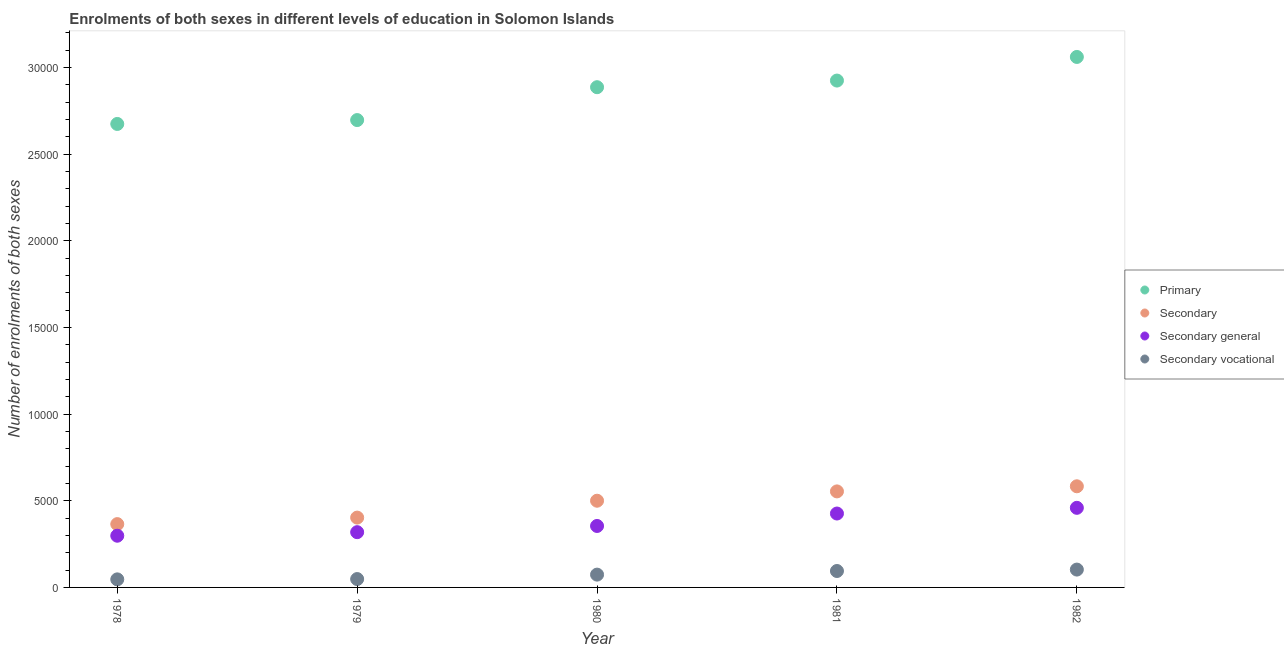How many different coloured dotlines are there?
Provide a short and direct response. 4. What is the number of enrolments in secondary vocational education in 1982?
Your response must be concise. 1030. Across all years, what is the maximum number of enrolments in primary education?
Provide a succinct answer. 3.06e+04. Across all years, what is the minimum number of enrolments in secondary general education?
Provide a short and direct response. 2984. In which year was the number of enrolments in secondary vocational education minimum?
Provide a succinct answer. 1978. What is the total number of enrolments in secondary education in the graph?
Offer a very short reply. 2.41e+04. What is the difference between the number of enrolments in secondary vocational education in 1979 and that in 1982?
Provide a succinct answer. -547. What is the difference between the number of enrolments in secondary general education in 1982 and the number of enrolments in secondary education in 1978?
Ensure brevity in your answer.  940. What is the average number of enrolments in primary education per year?
Give a very brief answer. 2.85e+04. In the year 1978, what is the difference between the number of enrolments in secondary general education and number of enrolments in primary education?
Offer a very short reply. -2.38e+04. In how many years, is the number of enrolments in secondary general education greater than 4000?
Your answer should be compact. 2. What is the ratio of the number of enrolments in primary education in 1979 to that in 1980?
Keep it short and to the point. 0.93. Is the number of enrolments in primary education in 1978 less than that in 1982?
Provide a short and direct response. Yes. What is the difference between the highest and the second highest number of enrolments in primary education?
Your answer should be very brief. 1363. What is the difference between the highest and the lowest number of enrolments in secondary general education?
Provide a short and direct response. 1610. In how many years, is the number of enrolments in secondary education greater than the average number of enrolments in secondary education taken over all years?
Give a very brief answer. 3. Is the number of enrolments in secondary vocational education strictly greater than the number of enrolments in secondary general education over the years?
Make the answer very short. No. Is the number of enrolments in secondary general education strictly less than the number of enrolments in primary education over the years?
Offer a terse response. Yes. How many dotlines are there?
Your response must be concise. 4. How many years are there in the graph?
Your answer should be very brief. 5. What is the difference between two consecutive major ticks on the Y-axis?
Provide a succinct answer. 5000. Are the values on the major ticks of Y-axis written in scientific E-notation?
Keep it short and to the point. No. Does the graph contain any zero values?
Give a very brief answer. No. How are the legend labels stacked?
Your answer should be compact. Vertical. What is the title of the graph?
Provide a short and direct response. Enrolments of both sexes in different levels of education in Solomon Islands. What is the label or title of the X-axis?
Ensure brevity in your answer.  Year. What is the label or title of the Y-axis?
Make the answer very short. Number of enrolments of both sexes. What is the Number of enrolments of both sexes in Primary in 1978?
Provide a succinct answer. 2.67e+04. What is the Number of enrolments of both sexes in Secondary in 1978?
Provide a short and direct response. 3654. What is the Number of enrolments of both sexes of Secondary general in 1978?
Offer a very short reply. 2984. What is the Number of enrolments of both sexes of Secondary vocational in 1978?
Your answer should be compact. 465. What is the Number of enrolments of both sexes in Primary in 1979?
Your response must be concise. 2.70e+04. What is the Number of enrolments of both sexes of Secondary in 1979?
Make the answer very short. 4030. What is the Number of enrolments of both sexes in Secondary general in 1979?
Your answer should be very brief. 3189. What is the Number of enrolments of both sexes in Secondary vocational in 1979?
Provide a short and direct response. 483. What is the Number of enrolments of both sexes of Primary in 1980?
Provide a succinct answer. 2.89e+04. What is the Number of enrolments of both sexes of Secondary in 1980?
Your answer should be compact. 5004. What is the Number of enrolments of both sexes of Secondary general in 1980?
Keep it short and to the point. 3547. What is the Number of enrolments of both sexes in Secondary vocational in 1980?
Offer a very short reply. 739. What is the Number of enrolments of both sexes in Primary in 1981?
Ensure brevity in your answer.  2.93e+04. What is the Number of enrolments of both sexes of Secondary in 1981?
Make the answer very short. 5542. What is the Number of enrolments of both sexes in Secondary general in 1981?
Ensure brevity in your answer.  4265. What is the Number of enrolments of both sexes in Secondary vocational in 1981?
Make the answer very short. 948. What is the Number of enrolments of both sexes in Primary in 1982?
Give a very brief answer. 3.06e+04. What is the Number of enrolments of both sexes of Secondary in 1982?
Offer a very short reply. 5837. What is the Number of enrolments of both sexes in Secondary general in 1982?
Offer a very short reply. 4594. What is the Number of enrolments of both sexes of Secondary vocational in 1982?
Offer a very short reply. 1030. Across all years, what is the maximum Number of enrolments of both sexes of Primary?
Provide a short and direct response. 3.06e+04. Across all years, what is the maximum Number of enrolments of both sexes of Secondary?
Provide a succinct answer. 5837. Across all years, what is the maximum Number of enrolments of both sexes of Secondary general?
Ensure brevity in your answer.  4594. Across all years, what is the maximum Number of enrolments of both sexes in Secondary vocational?
Your answer should be compact. 1030. Across all years, what is the minimum Number of enrolments of both sexes of Primary?
Make the answer very short. 2.67e+04. Across all years, what is the minimum Number of enrolments of both sexes of Secondary?
Make the answer very short. 3654. Across all years, what is the minimum Number of enrolments of both sexes in Secondary general?
Your answer should be compact. 2984. Across all years, what is the minimum Number of enrolments of both sexes of Secondary vocational?
Your answer should be compact. 465. What is the total Number of enrolments of both sexes in Primary in the graph?
Make the answer very short. 1.42e+05. What is the total Number of enrolments of both sexes of Secondary in the graph?
Ensure brevity in your answer.  2.41e+04. What is the total Number of enrolments of both sexes of Secondary general in the graph?
Offer a terse response. 1.86e+04. What is the total Number of enrolments of both sexes in Secondary vocational in the graph?
Your response must be concise. 3665. What is the difference between the Number of enrolments of both sexes of Primary in 1978 and that in 1979?
Keep it short and to the point. -224. What is the difference between the Number of enrolments of both sexes of Secondary in 1978 and that in 1979?
Give a very brief answer. -376. What is the difference between the Number of enrolments of both sexes of Secondary general in 1978 and that in 1979?
Provide a short and direct response. -205. What is the difference between the Number of enrolments of both sexes of Primary in 1978 and that in 1980?
Your response must be concise. -2121. What is the difference between the Number of enrolments of both sexes in Secondary in 1978 and that in 1980?
Give a very brief answer. -1350. What is the difference between the Number of enrolments of both sexes of Secondary general in 1978 and that in 1980?
Ensure brevity in your answer.  -563. What is the difference between the Number of enrolments of both sexes of Secondary vocational in 1978 and that in 1980?
Your answer should be very brief. -274. What is the difference between the Number of enrolments of both sexes of Primary in 1978 and that in 1981?
Provide a short and direct response. -2504. What is the difference between the Number of enrolments of both sexes in Secondary in 1978 and that in 1981?
Offer a very short reply. -1888. What is the difference between the Number of enrolments of both sexes of Secondary general in 1978 and that in 1981?
Keep it short and to the point. -1281. What is the difference between the Number of enrolments of both sexes in Secondary vocational in 1978 and that in 1981?
Your response must be concise. -483. What is the difference between the Number of enrolments of both sexes of Primary in 1978 and that in 1982?
Keep it short and to the point. -3867. What is the difference between the Number of enrolments of both sexes of Secondary in 1978 and that in 1982?
Offer a terse response. -2183. What is the difference between the Number of enrolments of both sexes in Secondary general in 1978 and that in 1982?
Provide a succinct answer. -1610. What is the difference between the Number of enrolments of both sexes in Secondary vocational in 1978 and that in 1982?
Your answer should be compact. -565. What is the difference between the Number of enrolments of both sexes of Primary in 1979 and that in 1980?
Provide a succinct answer. -1897. What is the difference between the Number of enrolments of both sexes of Secondary in 1979 and that in 1980?
Keep it short and to the point. -974. What is the difference between the Number of enrolments of both sexes in Secondary general in 1979 and that in 1980?
Give a very brief answer. -358. What is the difference between the Number of enrolments of both sexes in Secondary vocational in 1979 and that in 1980?
Keep it short and to the point. -256. What is the difference between the Number of enrolments of both sexes in Primary in 1979 and that in 1981?
Ensure brevity in your answer.  -2280. What is the difference between the Number of enrolments of both sexes in Secondary in 1979 and that in 1981?
Give a very brief answer. -1512. What is the difference between the Number of enrolments of both sexes of Secondary general in 1979 and that in 1981?
Your response must be concise. -1076. What is the difference between the Number of enrolments of both sexes in Secondary vocational in 1979 and that in 1981?
Offer a terse response. -465. What is the difference between the Number of enrolments of both sexes of Primary in 1979 and that in 1982?
Keep it short and to the point. -3643. What is the difference between the Number of enrolments of both sexes of Secondary in 1979 and that in 1982?
Keep it short and to the point. -1807. What is the difference between the Number of enrolments of both sexes of Secondary general in 1979 and that in 1982?
Make the answer very short. -1405. What is the difference between the Number of enrolments of both sexes of Secondary vocational in 1979 and that in 1982?
Your response must be concise. -547. What is the difference between the Number of enrolments of both sexes in Primary in 1980 and that in 1981?
Offer a very short reply. -383. What is the difference between the Number of enrolments of both sexes of Secondary in 1980 and that in 1981?
Provide a succinct answer. -538. What is the difference between the Number of enrolments of both sexes of Secondary general in 1980 and that in 1981?
Ensure brevity in your answer.  -718. What is the difference between the Number of enrolments of both sexes in Secondary vocational in 1980 and that in 1981?
Make the answer very short. -209. What is the difference between the Number of enrolments of both sexes in Primary in 1980 and that in 1982?
Your response must be concise. -1746. What is the difference between the Number of enrolments of both sexes of Secondary in 1980 and that in 1982?
Give a very brief answer. -833. What is the difference between the Number of enrolments of both sexes in Secondary general in 1980 and that in 1982?
Your response must be concise. -1047. What is the difference between the Number of enrolments of both sexes of Secondary vocational in 1980 and that in 1982?
Offer a terse response. -291. What is the difference between the Number of enrolments of both sexes in Primary in 1981 and that in 1982?
Keep it short and to the point. -1363. What is the difference between the Number of enrolments of both sexes in Secondary in 1981 and that in 1982?
Provide a succinct answer. -295. What is the difference between the Number of enrolments of both sexes in Secondary general in 1981 and that in 1982?
Offer a terse response. -329. What is the difference between the Number of enrolments of both sexes in Secondary vocational in 1981 and that in 1982?
Give a very brief answer. -82. What is the difference between the Number of enrolments of both sexes of Primary in 1978 and the Number of enrolments of both sexes of Secondary in 1979?
Provide a short and direct response. 2.27e+04. What is the difference between the Number of enrolments of both sexes in Primary in 1978 and the Number of enrolments of both sexes in Secondary general in 1979?
Offer a very short reply. 2.36e+04. What is the difference between the Number of enrolments of both sexes of Primary in 1978 and the Number of enrolments of both sexes of Secondary vocational in 1979?
Provide a succinct answer. 2.63e+04. What is the difference between the Number of enrolments of both sexes in Secondary in 1978 and the Number of enrolments of both sexes in Secondary general in 1979?
Provide a short and direct response. 465. What is the difference between the Number of enrolments of both sexes of Secondary in 1978 and the Number of enrolments of both sexes of Secondary vocational in 1979?
Your answer should be very brief. 3171. What is the difference between the Number of enrolments of both sexes of Secondary general in 1978 and the Number of enrolments of both sexes of Secondary vocational in 1979?
Offer a terse response. 2501. What is the difference between the Number of enrolments of both sexes in Primary in 1978 and the Number of enrolments of both sexes in Secondary in 1980?
Provide a succinct answer. 2.17e+04. What is the difference between the Number of enrolments of both sexes in Primary in 1978 and the Number of enrolments of both sexes in Secondary general in 1980?
Provide a succinct answer. 2.32e+04. What is the difference between the Number of enrolments of both sexes of Primary in 1978 and the Number of enrolments of both sexes of Secondary vocational in 1980?
Provide a succinct answer. 2.60e+04. What is the difference between the Number of enrolments of both sexes of Secondary in 1978 and the Number of enrolments of both sexes of Secondary general in 1980?
Offer a very short reply. 107. What is the difference between the Number of enrolments of both sexes of Secondary in 1978 and the Number of enrolments of both sexes of Secondary vocational in 1980?
Give a very brief answer. 2915. What is the difference between the Number of enrolments of both sexes in Secondary general in 1978 and the Number of enrolments of both sexes in Secondary vocational in 1980?
Your answer should be compact. 2245. What is the difference between the Number of enrolments of both sexes of Primary in 1978 and the Number of enrolments of both sexes of Secondary in 1981?
Make the answer very short. 2.12e+04. What is the difference between the Number of enrolments of both sexes of Primary in 1978 and the Number of enrolments of both sexes of Secondary general in 1981?
Provide a succinct answer. 2.25e+04. What is the difference between the Number of enrolments of both sexes in Primary in 1978 and the Number of enrolments of both sexes in Secondary vocational in 1981?
Offer a terse response. 2.58e+04. What is the difference between the Number of enrolments of both sexes in Secondary in 1978 and the Number of enrolments of both sexes in Secondary general in 1981?
Provide a succinct answer. -611. What is the difference between the Number of enrolments of both sexes of Secondary in 1978 and the Number of enrolments of both sexes of Secondary vocational in 1981?
Ensure brevity in your answer.  2706. What is the difference between the Number of enrolments of both sexes of Secondary general in 1978 and the Number of enrolments of both sexes of Secondary vocational in 1981?
Provide a succinct answer. 2036. What is the difference between the Number of enrolments of both sexes of Primary in 1978 and the Number of enrolments of both sexes of Secondary in 1982?
Offer a terse response. 2.09e+04. What is the difference between the Number of enrolments of both sexes of Primary in 1978 and the Number of enrolments of both sexes of Secondary general in 1982?
Your response must be concise. 2.22e+04. What is the difference between the Number of enrolments of both sexes in Primary in 1978 and the Number of enrolments of both sexes in Secondary vocational in 1982?
Offer a very short reply. 2.57e+04. What is the difference between the Number of enrolments of both sexes of Secondary in 1978 and the Number of enrolments of both sexes of Secondary general in 1982?
Provide a short and direct response. -940. What is the difference between the Number of enrolments of both sexes in Secondary in 1978 and the Number of enrolments of both sexes in Secondary vocational in 1982?
Provide a short and direct response. 2624. What is the difference between the Number of enrolments of both sexes in Secondary general in 1978 and the Number of enrolments of both sexes in Secondary vocational in 1982?
Make the answer very short. 1954. What is the difference between the Number of enrolments of both sexes in Primary in 1979 and the Number of enrolments of both sexes in Secondary in 1980?
Offer a terse response. 2.20e+04. What is the difference between the Number of enrolments of both sexes in Primary in 1979 and the Number of enrolments of both sexes in Secondary general in 1980?
Provide a short and direct response. 2.34e+04. What is the difference between the Number of enrolments of both sexes in Primary in 1979 and the Number of enrolments of both sexes in Secondary vocational in 1980?
Your answer should be very brief. 2.62e+04. What is the difference between the Number of enrolments of both sexes in Secondary in 1979 and the Number of enrolments of both sexes in Secondary general in 1980?
Your response must be concise. 483. What is the difference between the Number of enrolments of both sexes in Secondary in 1979 and the Number of enrolments of both sexes in Secondary vocational in 1980?
Your answer should be compact. 3291. What is the difference between the Number of enrolments of both sexes of Secondary general in 1979 and the Number of enrolments of both sexes of Secondary vocational in 1980?
Provide a succinct answer. 2450. What is the difference between the Number of enrolments of both sexes in Primary in 1979 and the Number of enrolments of both sexes in Secondary in 1981?
Provide a succinct answer. 2.14e+04. What is the difference between the Number of enrolments of both sexes in Primary in 1979 and the Number of enrolments of both sexes in Secondary general in 1981?
Keep it short and to the point. 2.27e+04. What is the difference between the Number of enrolments of both sexes in Primary in 1979 and the Number of enrolments of both sexes in Secondary vocational in 1981?
Provide a short and direct response. 2.60e+04. What is the difference between the Number of enrolments of both sexes of Secondary in 1979 and the Number of enrolments of both sexes of Secondary general in 1981?
Provide a succinct answer. -235. What is the difference between the Number of enrolments of both sexes of Secondary in 1979 and the Number of enrolments of both sexes of Secondary vocational in 1981?
Offer a very short reply. 3082. What is the difference between the Number of enrolments of both sexes of Secondary general in 1979 and the Number of enrolments of both sexes of Secondary vocational in 1981?
Ensure brevity in your answer.  2241. What is the difference between the Number of enrolments of both sexes in Primary in 1979 and the Number of enrolments of both sexes in Secondary in 1982?
Your answer should be compact. 2.11e+04. What is the difference between the Number of enrolments of both sexes in Primary in 1979 and the Number of enrolments of both sexes in Secondary general in 1982?
Your answer should be compact. 2.24e+04. What is the difference between the Number of enrolments of both sexes in Primary in 1979 and the Number of enrolments of both sexes in Secondary vocational in 1982?
Ensure brevity in your answer.  2.59e+04. What is the difference between the Number of enrolments of both sexes of Secondary in 1979 and the Number of enrolments of both sexes of Secondary general in 1982?
Provide a short and direct response. -564. What is the difference between the Number of enrolments of both sexes in Secondary in 1979 and the Number of enrolments of both sexes in Secondary vocational in 1982?
Offer a very short reply. 3000. What is the difference between the Number of enrolments of both sexes of Secondary general in 1979 and the Number of enrolments of both sexes of Secondary vocational in 1982?
Give a very brief answer. 2159. What is the difference between the Number of enrolments of both sexes in Primary in 1980 and the Number of enrolments of both sexes in Secondary in 1981?
Ensure brevity in your answer.  2.33e+04. What is the difference between the Number of enrolments of both sexes in Primary in 1980 and the Number of enrolments of both sexes in Secondary general in 1981?
Make the answer very short. 2.46e+04. What is the difference between the Number of enrolments of both sexes of Primary in 1980 and the Number of enrolments of both sexes of Secondary vocational in 1981?
Provide a succinct answer. 2.79e+04. What is the difference between the Number of enrolments of both sexes of Secondary in 1980 and the Number of enrolments of both sexes of Secondary general in 1981?
Make the answer very short. 739. What is the difference between the Number of enrolments of both sexes of Secondary in 1980 and the Number of enrolments of both sexes of Secondary vocational in 1981?
Offer a terse response. 4056. What is the difference between the Number of enrolments of both sexes of Secondary general in 1980 and the Number of enrolments of both sexes of Secondary vocational in 1981?
Your answer should be compact. 2599. What is the difference between the Number of enrolments of both sexes in Primary in 1980 and the Number of enrolments of both sexes in Secondary in 1982?
Your response must be concise. 2.30e+04. What is the difference between the Number of enrolments of both sexes in Primary in 1980 and the Number of enrolments of both sexes in Secondary general in 1982?
Your answer should be very brief. 2.43e+04. What is the difference between the Number of enrolments of both sexes of Primary in 1980 and the Number of enrolments of both sexes of Secondary vocational in 1982?
Your response must be concise. 2.78e+04. What is the difference between the Number of enrolments of both sexes of Secondary in 1980 and the Number of enrolments of both sexes of Secondary general in 1982?
Make the answer very short. 410. What is the difference between the Number of enrolments of both sexes in Secondary in 1980 and the Number of enrolments of both sexes in Secondary vocational in 1982?
Your answer should be compact. 3974. What is the difference between the Number of enrolments of both sexes of Secondary general in 1980 and the Number of enrolments of both sexes of Secondary vocational in 1982?
Provide a succinct answer. 2517. What is the difference between the Number of enrolments of both sexes in Primary in 1981 and the Number of enrolments of both sexes in Secondary in 1982?
Provide a succinct answer. 2.34e+04. What is the difference between the Number of enrolments of both sexes of Primary in 1981 and the Number of enrolments of both sexes of Secondary general in 1982?
Your answer should be compact. 2.47e+04. What is the difference between the Number of enrolments of both sexes of Primary in 1981 and the Number of enrolments of both sexes of Secondary vocational in 1982?
Give a very brief answer. 2.82e+04. What is the difference between the Number of enrolments of both sexes in Secondary in 1981 and the Number of enrolments of both sexes in Secondary general in 1982?
Keep it short and to the point. 948. What is the difference between the Number of enrolments of both sexes of Secondary in 1981 and the Number of enrolments of both sexes of Secondary vocational in 1982?
Make the answer very short. 4512. What is the difference between the Number of enrolments of both sexes in Secondary general in 1981 and the Number of enrolments of both sexes in Secondary vocational in 1982?
Offer a very short reply. 3235. What is the average Number of enrolments of both sexes in Primary per year?
Provide a short and direct response. 2.85e+04. What is the average Number of enrolments of both sexes in Secondary per year?
Make the answer very short. 4813.4. What is the average Number of enrolments of both sexes of Secondary general per year?
Your response must be concise. 3715.8. What is the average Number of enrolments of both sexes in Secondary vocational per year?
Provide a succinct answer. 733. In the year 1978, what is the difference between the Number of enrolments of both sexes of Primary and Number of enrolments of both sexes of Secondary?
Offer a terse response. 2.31e+04. In the year 1978, what is the difference between the Number of enrolments of both sexes in Primary and Number of enrolments of both sexes in Secondary general?
Your response must be concise. 2.38e+04. In the year 1978, what is the difference between the Number of enrolments of both sexes in Primary and Number of enrolments of both sexes in Secondary vocational?
Offer a very short reply. 2.63e+04. In the year 1978, what is the difference between the Number of enrolments of both sexes of Secondary and Number of enrolments of both sexes of Secondary general?
Provide a short and direct response. 670. In the year 1978, what is the difference between the Number of enrolments of both sexes in Secondary and Number of enrolments of both sexes in Secondary vocational?
Provide a short and direct response. 3189. In the year 1978, what is the difference between the Number of enrolments of both sexes in Secondary general and Number of enrolments of both sexes in Secondary vocational?
Offer a very short reply. 2519. In the year 1979, what is the difference between the Number of enrolments of both sexes in Primary and Number of enrolments of both sexes in Secondary?
Make the answer very short. 2.29e+04. In the year 1979, what is the difference between the Number of enrolments of both sexes in Primary and Number of enrolments of both sexes in Secondary general?
Give a very brief answer. 2.38e+04. In the year 1979, what is the difference between the Number of enrolments of both sexes of Primary and Number of enrolments of both sexes of Secondary vocational?
Your answer should be very brief. 2.65e+04. In the year 1979, what is the difference between the Number of enrolments of both sexes in Secondary and Number of enrolments of both sexes in Secondary general?
Make the answer very short. 841. In the year 1979, what is the difference between the Number of enrolments of both sexes in Secondary and Number of enrolments of both sexes in Secondary vocational?
Make the answer very short. 3547. In the year 1979, what is the difference between the Number of enrolments of both sexes in Secondary general and Number of enrolments of both sexes in Secondary vocational?
Your answer should be very brief. 2706. In the year 1980, what is the difference between the Number of enrolments of both sexes in Primary and Number of enrolments of both sexes in Secondary?
Offer a terse response. 2.39e+04. In the year 1980, what is the difference between the Number of enrolments of both sexes of Primary and Number of enrolments of both sexes of Secondary general?
Your answer should be compact. 2.53e+04. In the year 1980, what is the difference between the Number of enrolments of both sexes of Primary and Number of enrolments of both sexes of Secondary vocational?
Your response must be concise. 2.81e+04. In the year 1980, what is the difference between the Number of enrolments of both sexes in Secondary and Number of enrolments of both sexes in Secondary general?
Ensure brevity in your answer.  1457. In the year 1980, what is the difference between the Number of enrolments of both sexes of Secondary and Number of enrolments of both sexes of Secondary vocational?
Your response must be concise. 4265. In the year 1980, what is the difference between the Number of enrolments of both sexes in Secondary general and Number of enrolments of both sexes in Secondary vocational?
Provide a short and direct response. 2808. In the year 1981, what is the difference between the Number of enrolments of both sexes in Primary and Number of enrolments of both sexes in Secondary?
Keep it short and to the point. 2.37e+04. In the year 1981, what is the difference between the Number of enrolments of both sexes of Primary and Number of enrolments of both sexes of Secondary general?
Your response must be concise. 2.50e+04. In the year 1981, what is the difference between the Number of enrolments of both sexes in Primary and Number of enrolments of both sexes in Secondary vocational?
Offer a terse response. 2.83e+04. In the year 1981, what is the difference between the Number of enrolments of both sexes in Secondary and Number of enrolments of both sexes in Secondary general?
Provide a short and direct response. 1277. In the year 1981, what is the difference between the Number of enrolments of both sexes in Secondary and Number of enrolments of both sexes in Secondary vocational?
Provide a short and direct response. 4594. In the year 1981, what is the difference between the Number of enrolments of both sexes in Secondary general and Number of enrolments of both sexes in Secondary vocational?
Offer a very short reply. 3317. In the year 1982, what is the difference between the Number of enrolments of both sexes of Primary and Number of enrolments of both sexes of Secondary?
Your response must be concise. 2.48e+04. In the year 1982, what is the difference between the Number of enrolments of both sexes in Primary and Number of enrolments of both sexes in Secondary general?
Ensure brevity in your answer.  2.60e+04. In the year 1982, what is the difference between the Number of enrolments of both sexes of Primary and Number of enrolments of both sexes of Secondary vocational?
Your answer should be compact. 2.96e+04. In the year 1982, what is the difference between the Number of enrolments of both sexes in Secondary and Number of enrolments of both sexes in Secondary general?
Ensure brevity in your answer.  1243. In the year 1982, what is the difference between the Number of enrolments of both sexes in Secondary and Number of enrolments of both sexes in Secondary vocational?
Keep it short and to the point. 4807. In the year 1982, what is the difference between the Number of enrolments of both sexes in Secondary general and Number of enrolments of both sexes in Secondary vocational?
Your answer should be compact. 3564. What is the ratio of the Number of enrolments of both sexes in Primary in 1978 to that in 1979?
Provide a short and direct response. 0.99. What is the ratio of the Number of enrolments of both sexes in Secondary in 1978 to that in 1979?
Keep it short and to the point. 0.91. What is the ratio of the Number of enrolments of both sexes of Secondary general in 1978 to that in 1979?
Offer a very short reply. 0.94. What is the ratio of the Number of enrolments of both sexes of Secondary vocational in 1978 to that in 1979?
Make the answer very short. 0.96. What is the ratio of the Number of enrolments of both sexes of Primary in 1978 to that in 1980?
Your response must be concise. 0.93. What is the ratio of the Number of enrolments of both sexes in Secondary in 1978 to that in 1980?
Make the answer very short. 0.73. What is the ratio of the Number of enrolments of both sexes in Secondary general in 1978 to that in 1980?
Provide a short and direct response. 0.84. What is the ratio of the Number of enrolments of both sexes of Secondary vocational in 1978 to that in 1980?
Provide a succinct answer. 0.63. What is the ratio of the Number of enrolments of both sexes of Primary in 1978 to that in 1981?
Provide a succinct answer. 0.91. What is the ratio of the Number of enrolments of both sexes in Secondary in 1978 to that in 1981?
Your answer should be compact. 0.66. What is the ratio of the Number of enrolments of both sexes of Secondary general in 1978 to that in 1981?
Your answer should be compact. 0.7. What is the ratio of the Number of enrolments of both sexes in Secondary vocational in 1978 to that in 1981?
Provide a short and direct response. 0.49. What is the ratio of the Number of enrolments of both sexes in Primary in 1978 to that in 1982?
Ensure brevity in your answer.  0.87. What is the ratio of the Number of enrolments of both sexes in Secondary in 1978 to that in 1982?
Offer a terse response. 0.63. What is the ratio of the Number of enrolments of both sexes in Secondary general in 1978 to that in 1982?
Your answer should be very brief. 0.65. What is the ratio of the Number of enrolments of both sexes in Secondary vocational in 1978 to that in 1982?
Offer a very short reply. 0.45. What is the ratio of the Number of enrolments of both sexes in Primary in 1979 to that in 1980?
Offer a very short reply. 0.93. What is the ratio of the Number of enrolments of both sexes of Secondary in 1979 to that in 1980?
Make the answer very short. 0.81. What is the ratio of the Number of enrolments of both sexes of Secondary general in 1979 to that in 1980?
Keep it short and to the point. 0.9. What is the ratio of the Number of enrolments of both sexes of Secondary vocational in 1979 to that in 1980?
Offer a very short reply. 0.65. What is the ratio of the Number of enrolments of both sexes in Primary in 1979 to that in 1981?
Make the answer very short. 0.92. What is the ratio of the Number of enrolments of both sexes in Secondary in 1979 to that in 1981?
Your answer should be very brief. 0.73. What is the ratio of the Number of enrolments of both sexes of Secondary general in 1979 to that in 1981?
Give a very brief answer. 0.75. What is the ratio of the Number of enrolments of both sexes in Secondary vocational in 1979 to that in 1981?
Your response must be concise. 0.51. What is the ratio of the Number of enrolments of both sexes in Primary in 1979 to that in 1982?
Offer a very short reply. 0.88. What is the ratio of the Number of enrolments of both sexes of Secondary in 1979 to that in 1982?
Your response must be concise. 0.69. What is the ratio of the Number of enrolments of both sexes in Secondary general in 1979 to that in 1982?
Give a very brief answer. 0.69. What is the ratio of the Number of enrolments of both sexes of Secondary vocational in 1979 to that in 1982?
Make the answer very short. 0.47. What is the ratio of the Number of enrolments of both sexes of Primary in 1980 to that in 1981?
Your response must be concise. 0.99. What is the ratio of the Number of enrolments of both sexes of Secondary in 1980 to that in 1981?
Your answer should be very brief. 0.9. What is the ratio of the Number of enrolments of both sexes of Secondary general in 1980 to that in 1981?
Provide a short and direct response. 0.83. What is the ratio of the Number of enrolments of both sexes in Secondary vocational in 1980 to that in 1981?
Make the answer very short. 0.78. What is the ratio of the Number of enrolments of both sexes in Primary in 1980 to that in 1982?
Offer a very short reply. 0.94. What is the ratio of the Number of enrolments of both sexes in Secondary in 1980 to that in 1982?
Make the answer very short. 0.86. What is the ratio of the Number of enrolments of both sexes of Secondary general in 1980 to that in 1982?
Provide a short and direct response. 0.77. What is the ratio of the Number of enrolments of both sexes of Secondary vocational in 1980 to that in 1982?
Your response must be concise. 0.72. What is the ratio of the Number of enrolments of both sexes in Primary in 1981 to that in 1982?
Give a very brief answer. 0.96. What is the ratio of the Number of enrolments of both sexes in Secondary in 1981 to that in 1982?
Ensure brevity in your answer.  0.95. What is the ratio of the Number of enrolments of both sexes in Secondary general in 1981 to that in 1982?
Offer a terse response. 0.93. What is the ratio of the Number of enrolments of both sexes in Secondary vocational in 1981 to that in 1982?
Provide a short and direct response. 0.92. What is the difference between the highest and the second highest Number of enrolments of both sexes in Primary?
Give a very brief answer. 1363. What is the difference between the highest and the second highest Number of enrolments of both sexes of Secondary?
Give a very brief answer. 295. What is the difference between the highest and the second highest Number of enrolments of both sexes of Secondary general?
Give a very brief answer. 329. What is the difference between the highest and the lowest Number of enrolments of both sexes in Primary?
Keep it short and to the point. 3867. What is the difference between the highest and the lowest Number of enrolments of both sexes in Secondary?
Your answer should be compact. 2183. What is the difference between the highest and the lowest Number of enrolments of both sexes in Secondary general?
Keep it short and to the point. 1610. What is the difference between the highest and the lowest Number of enrolments of both sexes in Secondary vocational?
Give a very brief answer. 565. 